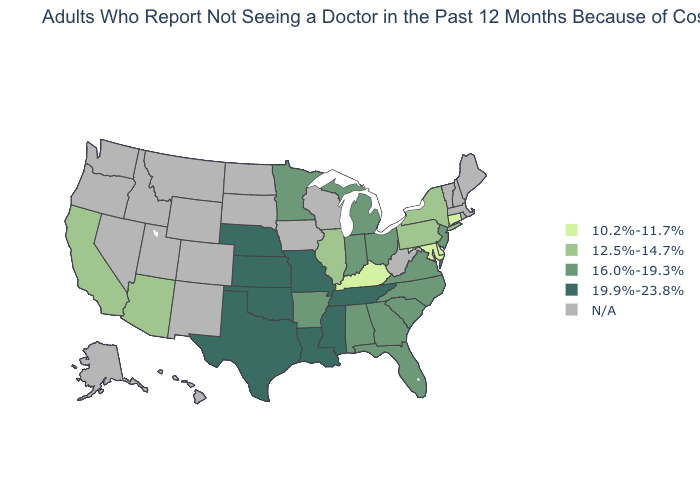Among the states that border Texas , does Oklahoma have the highest value?
Give a very brief answer. Yes. What is the value of Kansas?
Quick response, please. 19.9%-23.8%. What is the lowest value in the USA?
Answer briefly. 10.2%-11.7%. Name the states that have a value in the range 10.2%-11.7%?
Keep it brief. Connecticut, Delaware, Kentucky, Maryland. What is the value of Colorado?
Keep it brief. N/A. Name the states that have a value in the range 16.0%-19.3%?
Write a very short answer. Alabama, Arkansas, Florida, Georgia, Indiana, Michigan, Minnesota, New Jersey, North Carolina, Ohio, South Carolina, Virginia. What is the value of Pennsylvania?
Concise answer only. 12.5%-14.7%. Does New Jersey have the highest value in the Northeast?
Short answer required. Yes. What is the value of Nevada?
Concise answer only. N/A. Name the states that have a value in the range 16.0%-19.3%?
Write a very short answer. Alabama, Arkansas, Florida, Georgia, Indiana, Michigan, Minnesota, New Jersey, North Carolina, Ohio, South Carolina, Virginia. What is the value of Tennessee?
Concise answer only. 19.9%-23.8%. Name the states that have a value in the range N/A?
Be succinct. Alaska, Colorado, Hawaii, Idaho, Iowa, Maine, Massachusetts, Montana, Nevada, New Hampshire, New Mexico, North Dakota, Oregon, Rhode Island, South Dakota, Utah, Vermont, Washington, West Virginia, Wisconsin, Wyoming. Which states have the highest value in the USA?
Write a very short answer. Kansas, Louisiana, Mississippi, Missouri, Nebraska, Oklahoma, Tennessee, Texas. What is the value of Wyoming?
Concise answer only. N/A. Name the states that have a value in the range N/A?
Write a very short answer. Alaska, Colorado, Hawaii, Idaho, Iowa, Maine, Massachusetts, Montana, Nevada, New Hampshire, New Mexico, North Dakota, Oregon, Rhode Island, South Dakota, Utah, Vermont, Washington, West Virginia, Wisconsin, Wyoming. 